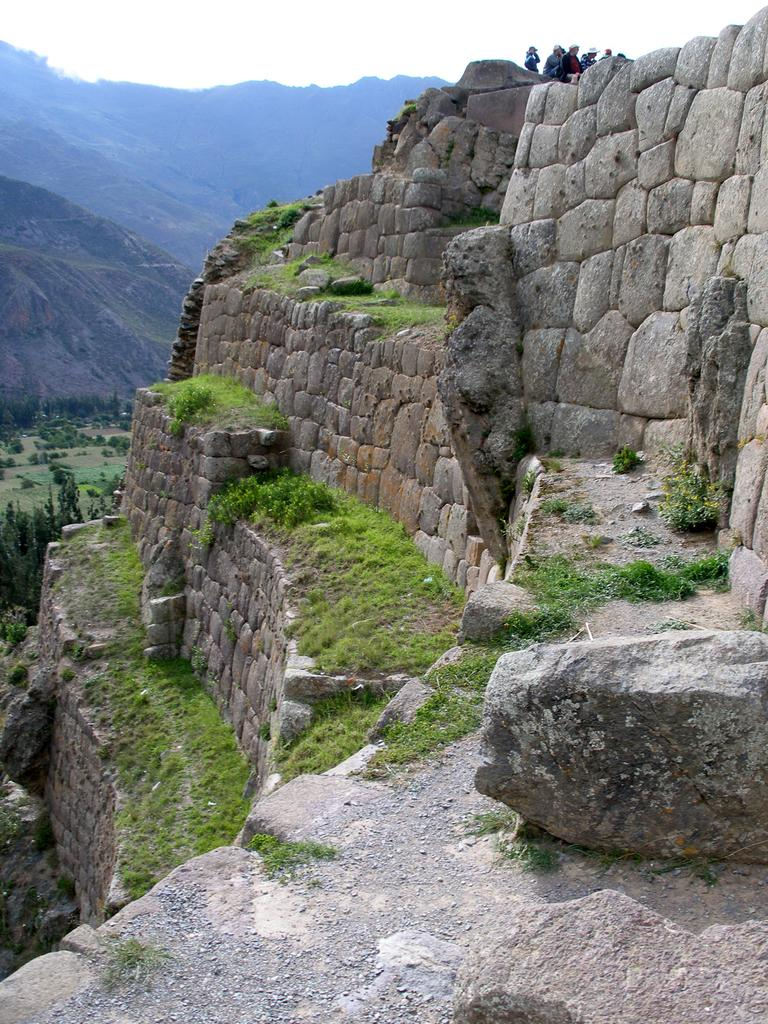How many people are in the image? There are people in the image, but the exact number is not specified. What type of terrain is visible in the image? There is grass, plants, trees, and hills visible in the image. What is visible in the background of the image? The sky is visible in the background of the image. What type of wax can be seen melting on the test in the image? There is no test or wax present in the image. What degree of difficulty can be observed in the image? The image does not depict a test or any activity that could be associated with a degree of difficulty. 